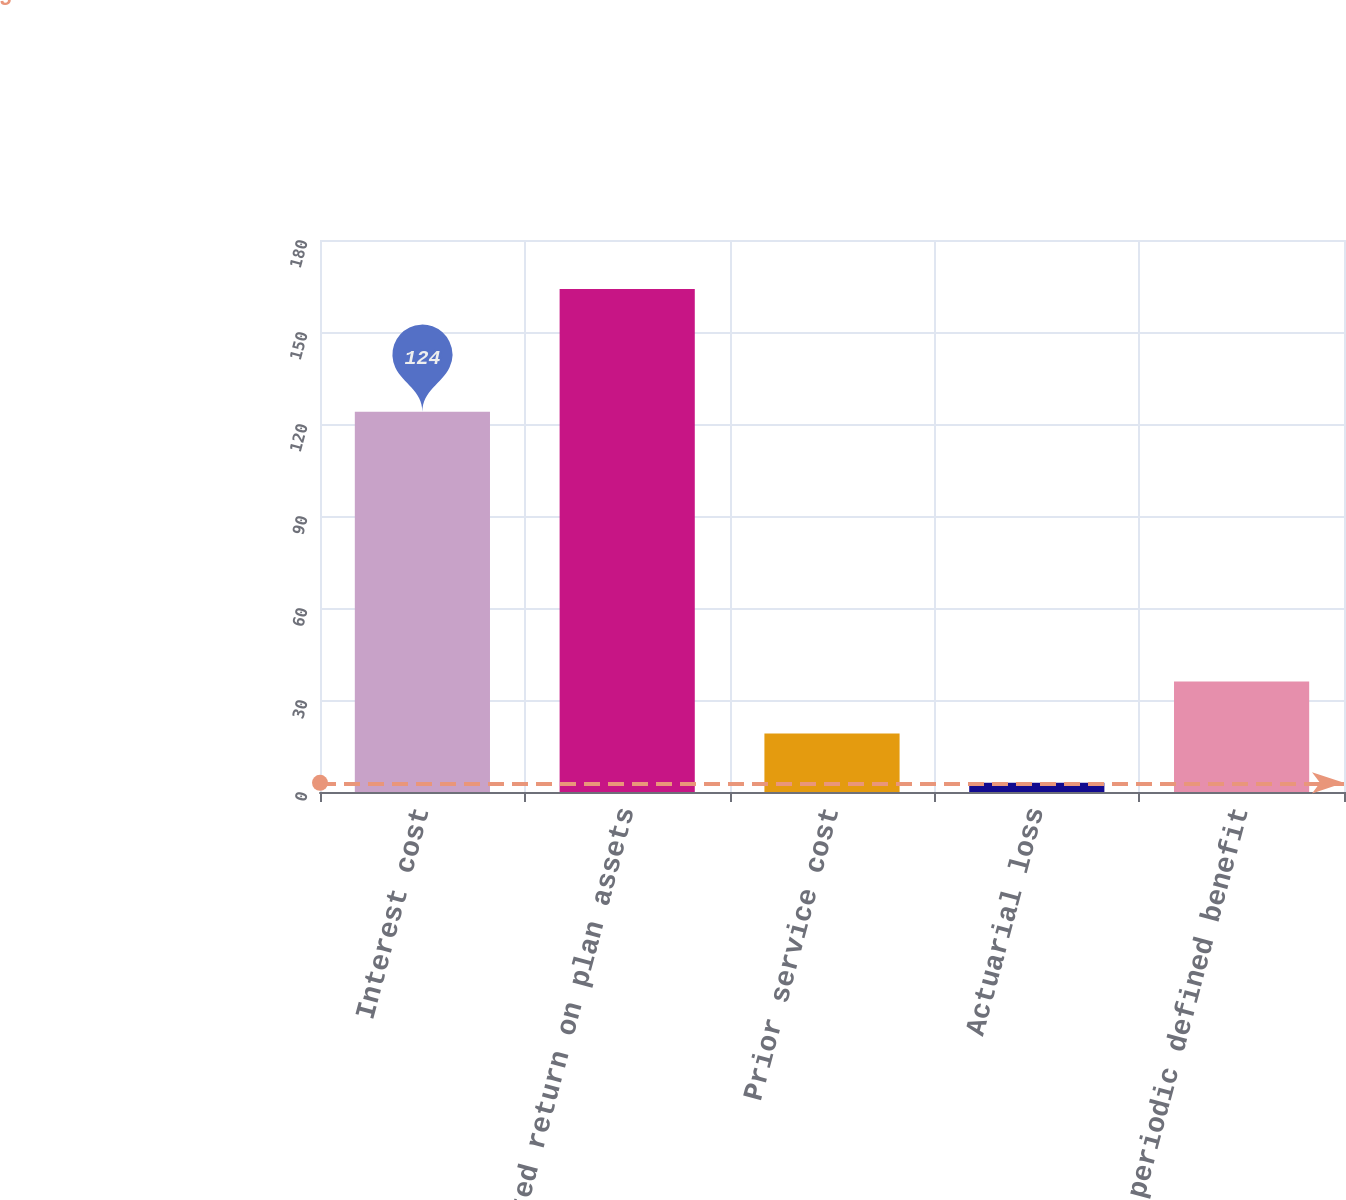Convert chart. <chart><loc_0><loc_0><loc_500><loc_500><bar_chart><fcel>Interest cost<fcel>Expected return on plan assets<fcel>Prior service cost<fcel>Actuarial loss<fcel>Net periodic defined benefit<nl><fcel>124<fcel>164<fcel>19.1<fcel>3<fcel>36<nl></chart> 